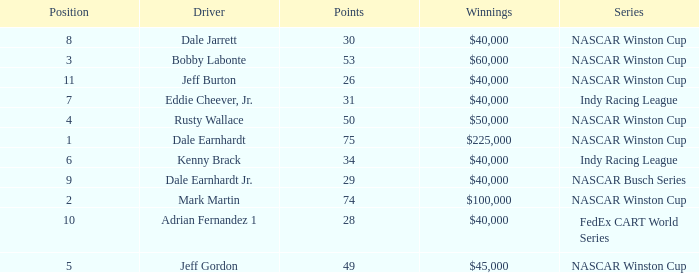In what position was the driver who won $60,000? 3.0. 